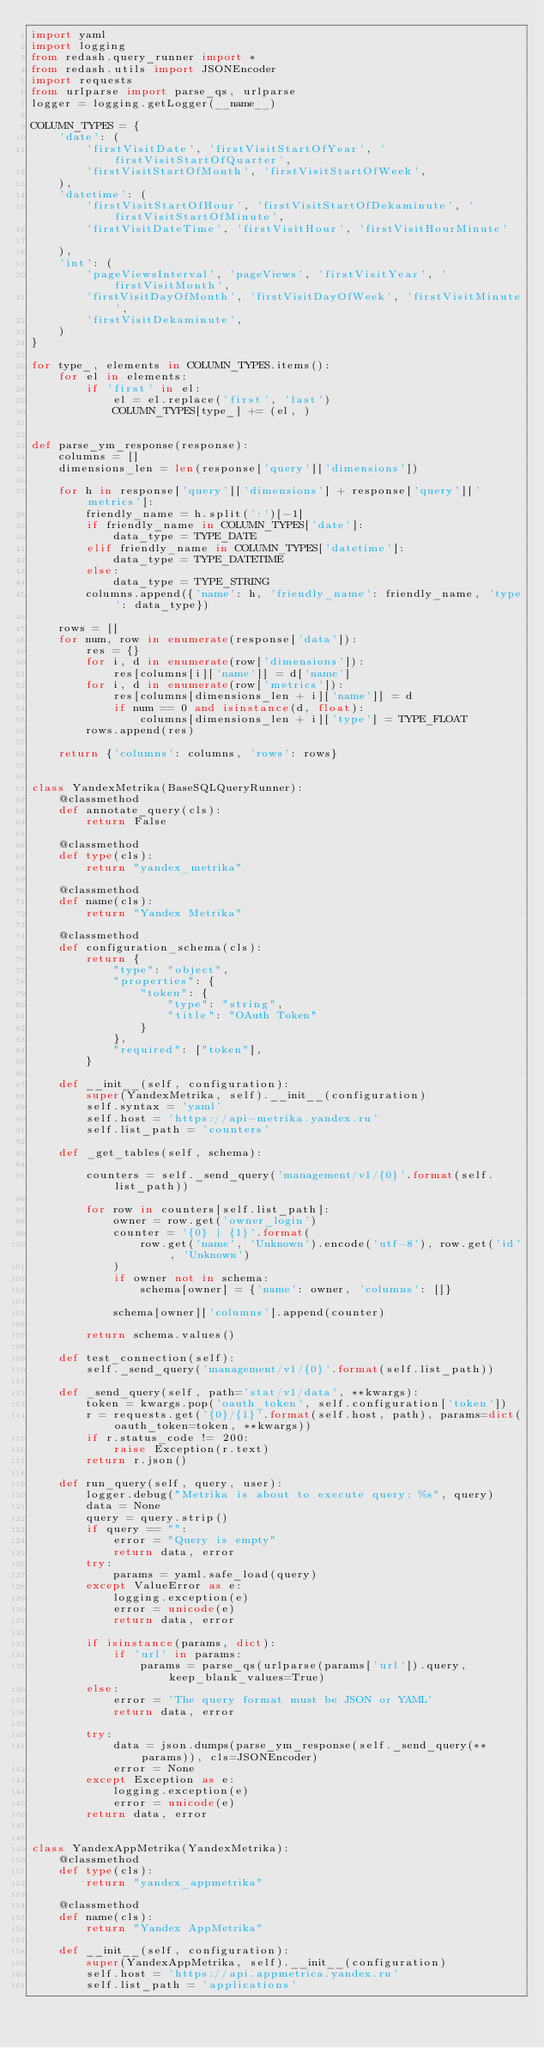Convert code to text. <code><loc_0><loc_0><loc_500><loc_500><_Python_>import yaml
import logging
from redash.query_runner import *
from redash.utils import JSONEncoder
import requests
from urlparse import parse_qs, urlparse
logger = logging.getLogger(__name__)

COLUMN_TYPES = {
    'date': (
        'firstVisitDate', 'firstVisitStartOfYear', 'firstVisitStartOfQuarter',
        'firstVisitStartOfMonth', 'firstVisitStartOfWeek',
    ),
    'datetime': (
        'firstVisitStartOfHour', 'firstVisitStartOfDekaminute', 'firstVisitStartOfMinute',
        'firstVisitDateTime', 'firstVisitHour', 'firstVisitHourMinute'

    ),
    'int': (
        'pageViewsInterval', 'pageViews', 'firstVisitYear', 'firstVisitMonth',
        'firstVisitDayOfMonth', 'firstVisitDayOfWeek', 'firstVisitMinute',
        'firstVisitDekaminute',
    )
}

for type_, elements in COLUMN_TYPES.items():
    for el in elements:
        if 'first' in el:
            el = el.replace('first', 'last')
            COLUMN_TYPES[type_] += (el, )


def parse_ym_response(response):
    columns = []
    dimensions_len = len(response['query']['dimensions'])
   
    for h in response['query']['dimensions'] + response['query']['metrics']:
        friendly_name = h.split(':')[-1]
        if friendly_name in COLUMN_TYPES['date']:
            data_type = TYPE_DATE
        elif friendly_name in COLUMN_TYPES['datetime']:
            data_type = TYPE_DATETIME
        else:
            data_type = TYPE_STRING
        columns.append({'name': h, 'friendly_name': friendly_name, 'type': data_type})

    rows = []
    for num, row in enumerate(response['data']):
        res = {}
        for i, d in enumerate(row['dimensions']):
            res[columns[i]['name']] = d['name']
        for i, d in enumerate(row['metrics']):
            res[columns[dimensions_len + i]['name']] = d
            if num == 0 and isinstance(d, float):
                columns[dimensions_len + i]['type'] = TYPE_FLOAT
        rows.append(res)

    return {'columns': columns, 'rows': rows}


class YandexMetrika(BaseSQLQueryRunner):
    @classmethod
    def annotate_query(cls):
        return False

    @classmethod
    def type(cls):
        return "yandex_metrika"

    @classmethod
    def name(cls):
        return "Yandex Metrika"

    @classmethod
    def configuration_schema(cls):
        return {
            "type": "object",
            "properties": {
                "token": {
                    "type": "string",
                    "title": "OAuth Token"
                }
            },
            "required": ["token"],
        }

    def __init__(self, configuration):
        super(YandexMetrika, self).__init__(configuration)
        self.syntax = 'yaml'
        self.host = 'https://api-metrika.yandex.ru'
        self.list_path = 'counters'

    def _get_tables(self, schema):

        counters = self._send_query('management/v1/{0}'.format(self.list_path))

        for row in counters[self.list_path]:
            owner = row.get('owner_login')
            counter = '{0} | {1}'.format(
                row.get('name', 'Unknown').encode('utf-8'), row.get('id', 'Unknown')
            )
            if owner not in schema:
                schema[owner] = {'name': owner, 'columns': []}

            schema[owner]['columns'].append(counter)

        return schema.values()

    def test_connection(self):
        self._send_query('management/v1/{0}'.format(self.list_path))

    def _send_query(self, path='stat/v1/data', **kwargs):
        token = kwargs.pop('oauth_token', self.configuration['token'])
        r = requests.get('{0}/{1}'.format(self.host, path), params=dict(oauth_token=token, **kwargs))
        if r.status_code != 200:
            raise Exception(r.text)
        return r.json()

    def run_query(self, query, user):
        logger.debug("Metrika is about to execute query: %s", query)
        data = None
        query = query.strip()
        if query == "":
            error = "Query is empty"
            return data, error
        try:
            params = yaml.safe_load(query)
        except ValueError as e:
            logging.exception(e)
            error = unicode(e)
            return data, error

        if isinstance(params, dict):
            if 'url' in params:
                params = parse_qs(urlparse(params['url']).query, keep_blank_values=True)
        else:
            error = 'The query format must be JSON or YAML'
            return data, error

        try:
            data = json.dumps(parse_ym_response(self._send_query(**params)), cls=JSONEncoder)
            error = None
        except Exception as e:
            logging.exception(e)
            error = unicode(e)
        return data, error


class YandexAppMetrika(YandexMetrika):
    @classmethod
    def type(cls):
        return "yandex_appmetrika"

    @classmethod
    def name(cls):
        return "Yandex AppMetrika"

    def __init__(self, configuration):
        super(YandexAppMetrika, self).__init__(configuration)
        self.host = 'https://api.appmetrica.yandex.ru'
        self.list_path = 'applications'

</code> 